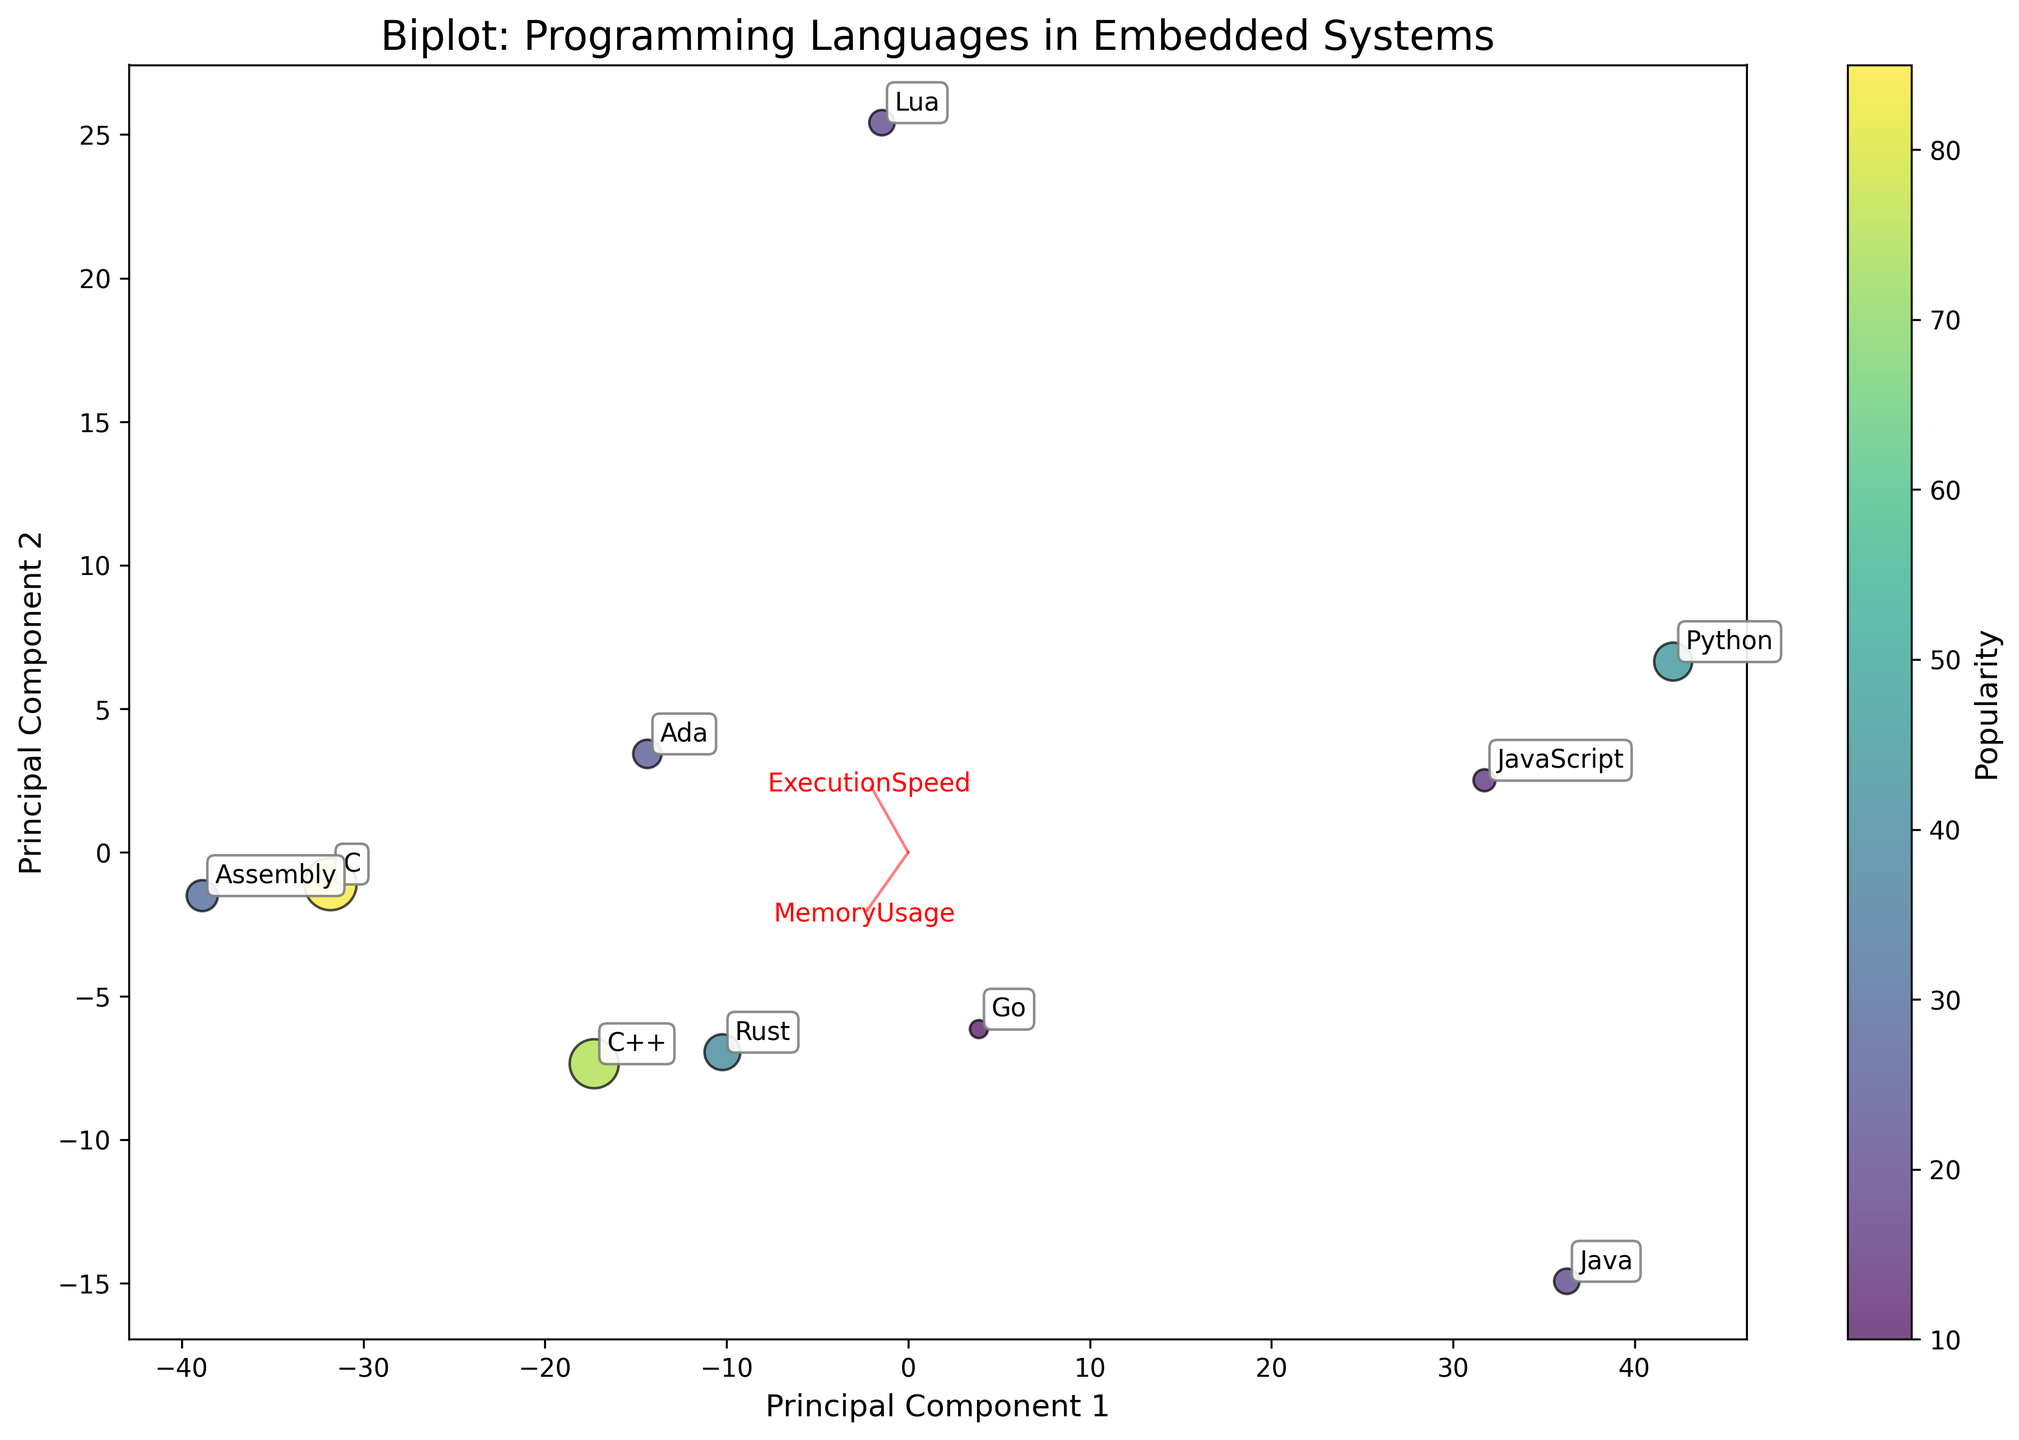How many data points are displayed in the biplot? Count the number of annotations or points displayed on the biplot.
Answer: 10 What are the two principal components labeled on the axes? Look at the labels on the x-axis and y-axis; these will tell us the two principal components.
Answer: Principal Component 1 and Principal Component 2 Which language appears closest to the arrow indicating high ExecutionSpeed and low MemoryUsage? Observe the arrows and the languages positioned near the arrow pointing toward the direction of high ExecutionSpeed and low MemoryUsage.
Answer: Assembly Which language seems to have the highest popularity based on size and color intensity of the points? Identify the point with the largest size and most intense color, which indicates higher popularity.
Answer: C What is the approximate direction of the feature vector for MemoryUsage? Look at the direction of the arrow labeled 'MemoryUsage'.
Answer: Points upward and slightly to the right Which languages have relatively high ExecutionSpeed but vary significantly in MemoryUsage? Observe the languages that are projected near the high ExecutionSpeed direction but are not clustered closely together in the MemoryUsage direction.
Answer: C and C++ Which languages appear to overlap in their composition of ExecutionSpeed and MemoryUsage? Look for points that are close to each other in the biplot.
Answer: Rust and Ada How does the popularity of Java compare to that of Python? Compare the size and color intensity of the points for Java and Python.
Answer: Python is more popular than Java What would be the relative position of languages with low ExecutionSpeed and high MemoryUsage on the biplot? Consider the direction of the feature vectors and determine where a point with low ExecutionSpeed and high MemoryUsage would fall.
Answer: Bottom right Do any languages appear to balance ExecutionSpeed and MemoryUsage moderately well? Look at the points that are near the middle of both ExecutionSpeed and MemoryUsage arrows.
Answer: Rust and Ada 